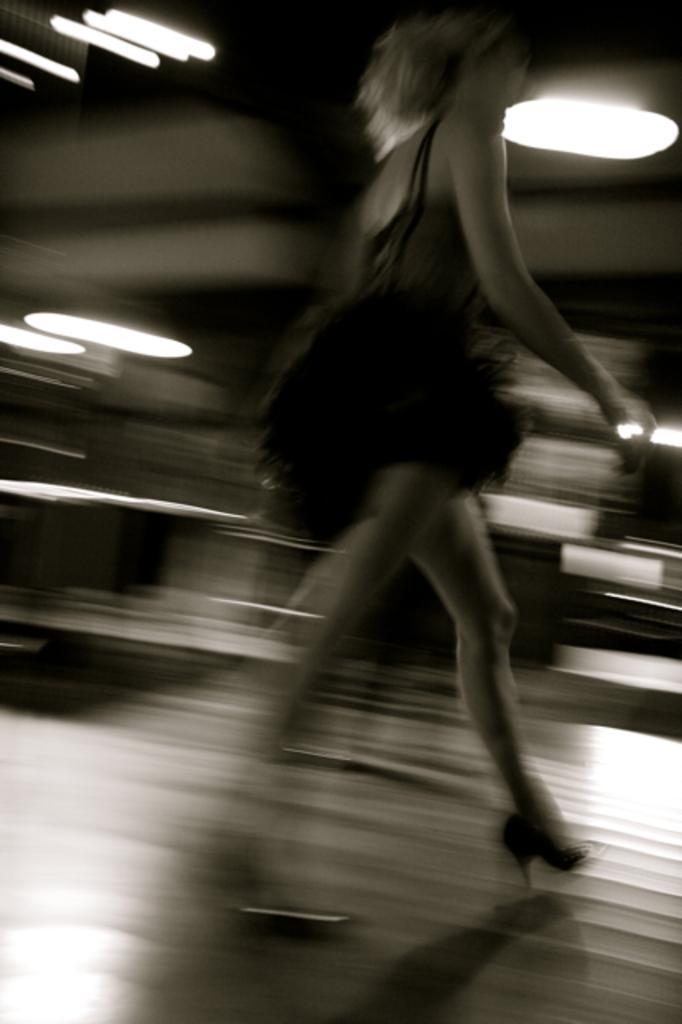How would you summarize this image in a sentence or two? In this image in the middle there is a woman, she wears a dress, she is walking. In the background there are lights. 